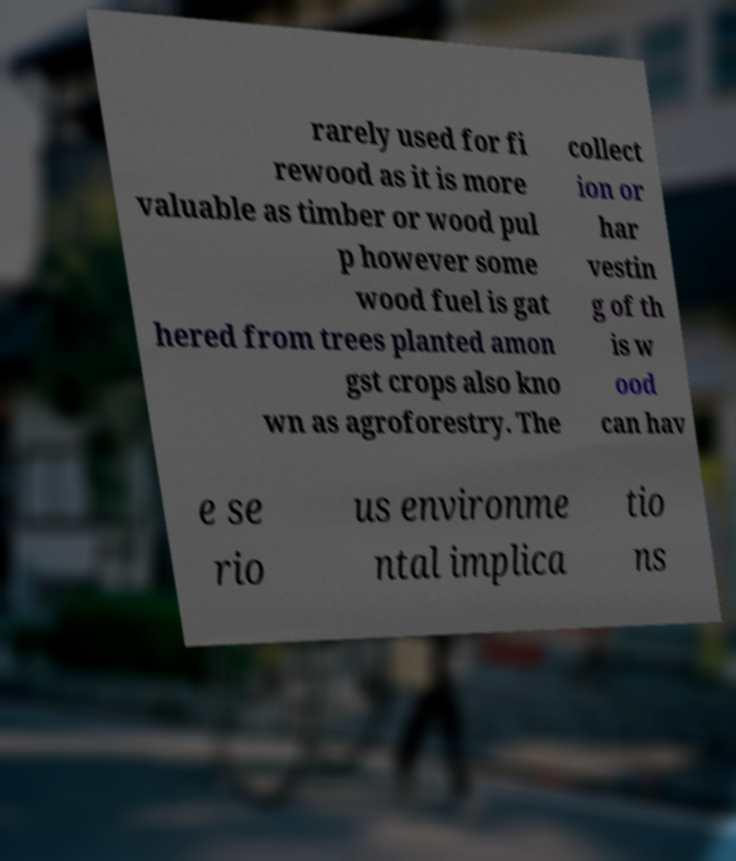Could you assist in decoding the text presented in this image and type it out clearly? rarely used for fi rewood as it is more valuable as timber or wood pul p however some wood fuel is gat hered from trees planted amon gst crops also kno wn as agroforestry. The collect ion or har vestin g of th is w ood can hav e se rio us environme ntal implica tio ns 